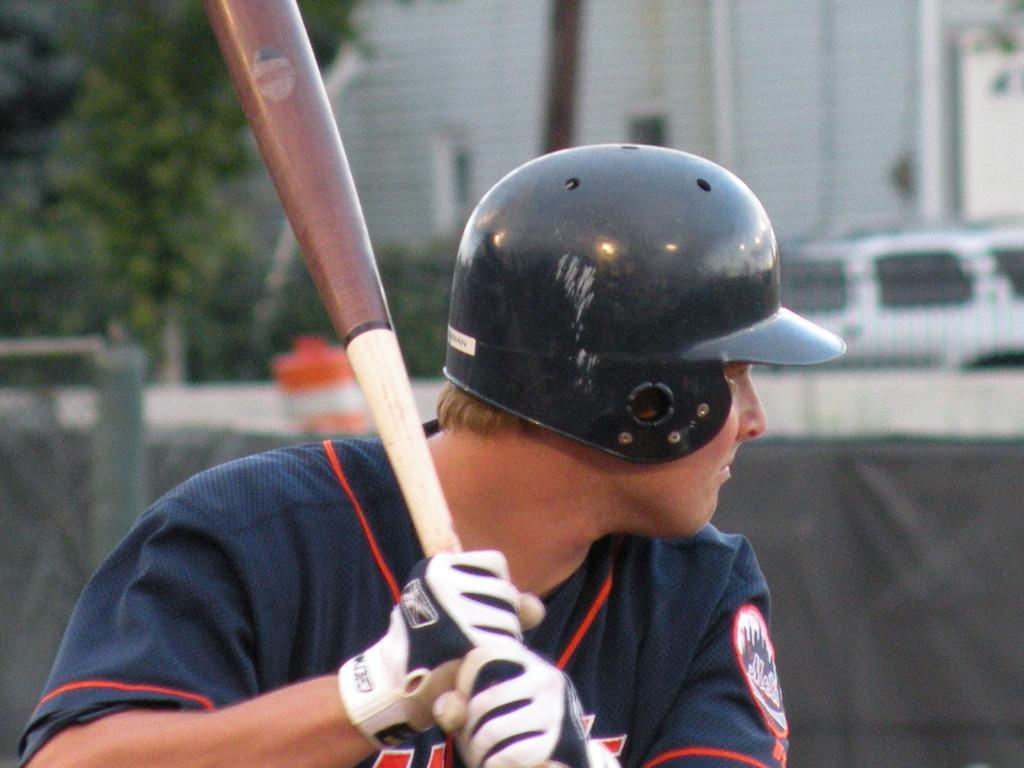Who is present in the image? There is a man in the image. What is the man wearing on his head? The man is wearing a helmet. What object is the man holding in the image? The man is holding a bat. What can be seen in the background of the image? There are trees, houses, and a car in the background of the image. How many lizards are sitting on the car in the image? There are no lizards present in the image, so it is not possible to determine how many might be sitting on the car. 